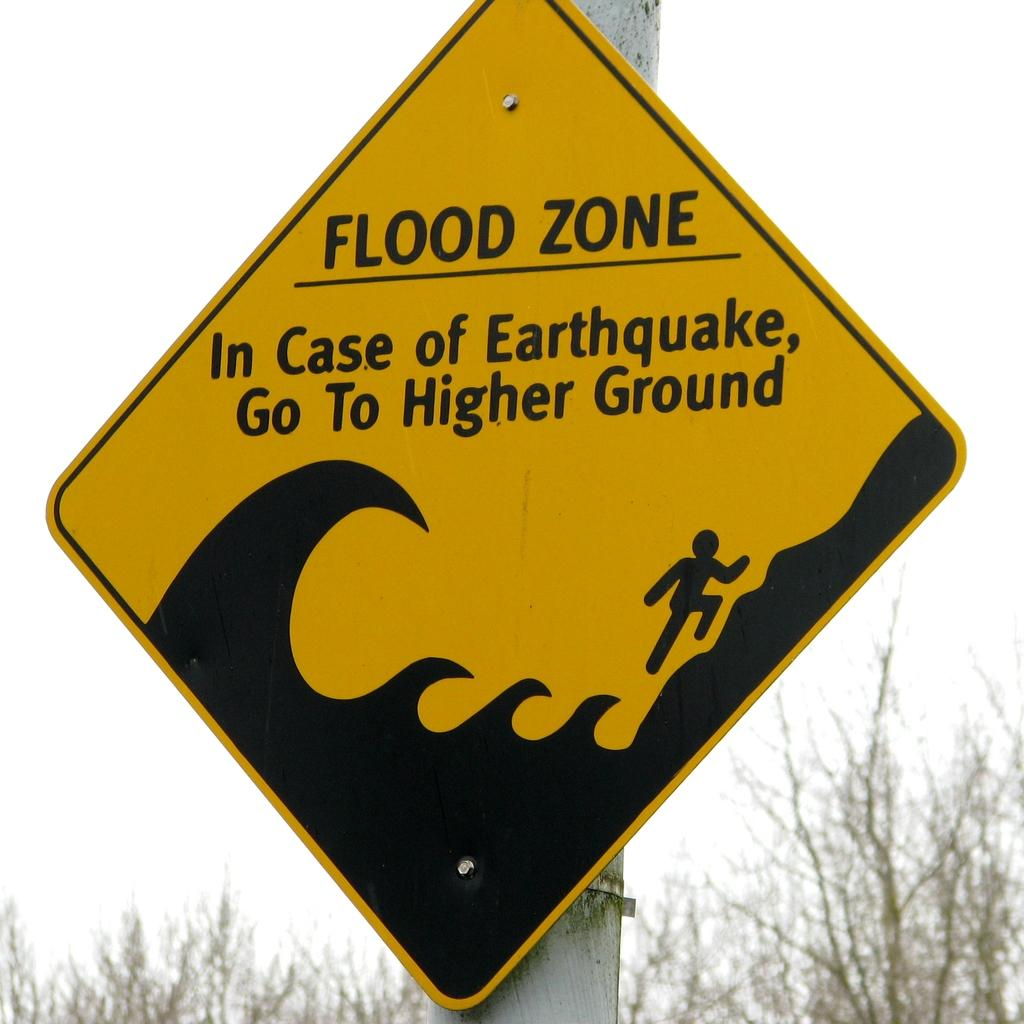<image>
Provide a brief description of the given image. A yellow sign warning of a Flood zone is posted. 